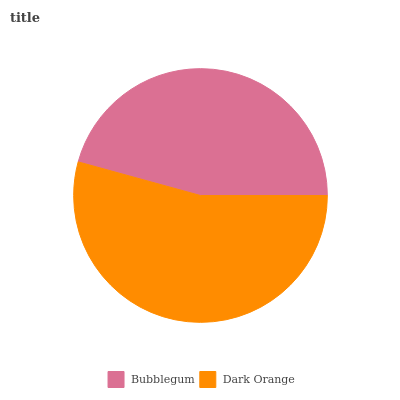Is Bubblegum the minimum?
Answer yes or no. Yes. Is Dark Orange the maximum?
Answer yes or no. Yes. Is Dark Orange the minimum?
Answer yes or no. No. Is Dark Orange greater than Bubblegum?
Answer yes or no. Yes. Is Bubblegum less than Dark Orange?
Answer yes or no. Yes. Is Bubblegum greater than Dark Orange?
Answer yes or no. No. Is Dark Orange less than Bubblegum?
Answer yes or no. No. Is Dark Orange the high median?
Answer yes or no. Yes. Is Bubblegum the low median?
Answer yes or no. Yes. Is Bubblegum the high median?
Answer yes or no. No. Is Dark Orange the low median?
Answer yes or no. No. 